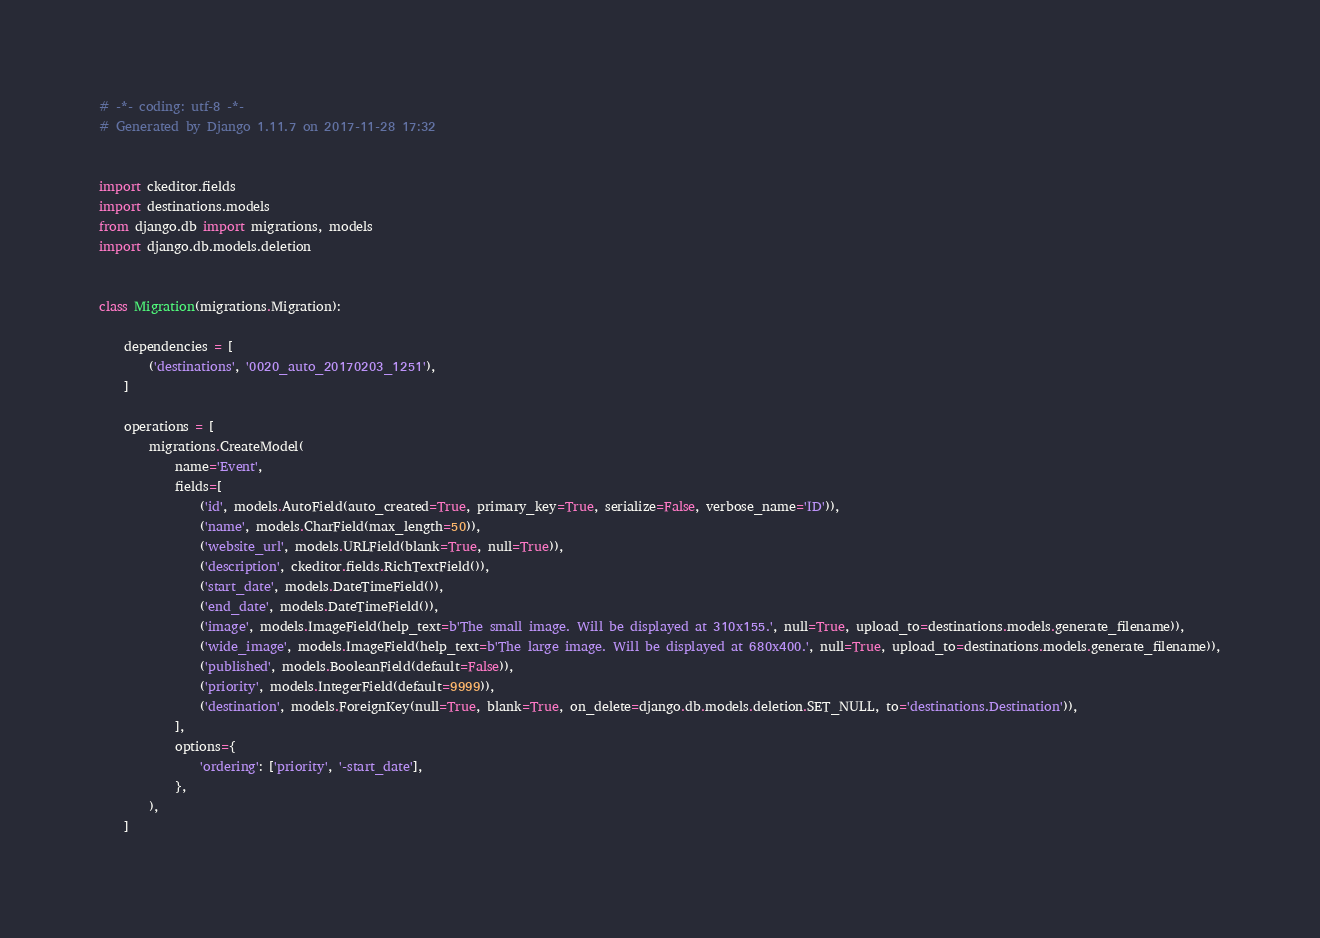Convert code to text. <code><loc_0><loc_0><loc_500><loc_500><_Python_># -*- coding: utf-8 -*-
# Generated by Django 1.11.7 on 2017-11-28 17:32


import ckeditor.fields
import destinations.models
from django.db import migrations, models
import django.db.models.deletion


class Migration(migrations.Migration):

    dependencies = [
        ('destinations', '0020_auto_20170203_1251'),
    ]

    operations = [
        migrations.CreateModel(
            name='Event',
            fields=[
                ('id', models.AutoField(auto_created=True, primary_key=True, serialize=False, verbose_name='ID')),
                ('name', models.CharField(max_length=50)),
                ('website_url', models.URLField(blank=True, null=True)),
                ('description', ckeditor.fields.RichTextField()),
                ('start_date', models.DateTimeField()),
                ('end_date', models.DateTimeField()),
                ('image', models.ImageField(help_text=b'The small image. Will be displayed at 310x155.', null=True, upload_to=destinations.models.generate_filename)),
                ('wide_image', models.ImageField(help_text=b'The large image. Will be displayed at 680x400.', null=True, upload_to=destinations.models.generate_filename)),
                ('published', models.BooleanField(default=False)),
                ('priority', models.IntegerField(default=9999)),
                ('destination', models.ForeignKey(null=True, blank=True, on_delete=django.db.models.deletion.SET_NULL, to='destinations.Destination')),
            ],
            options={
                'ordering': ['priority', '-start_date'],
            },
        ),
    ]
</code> 